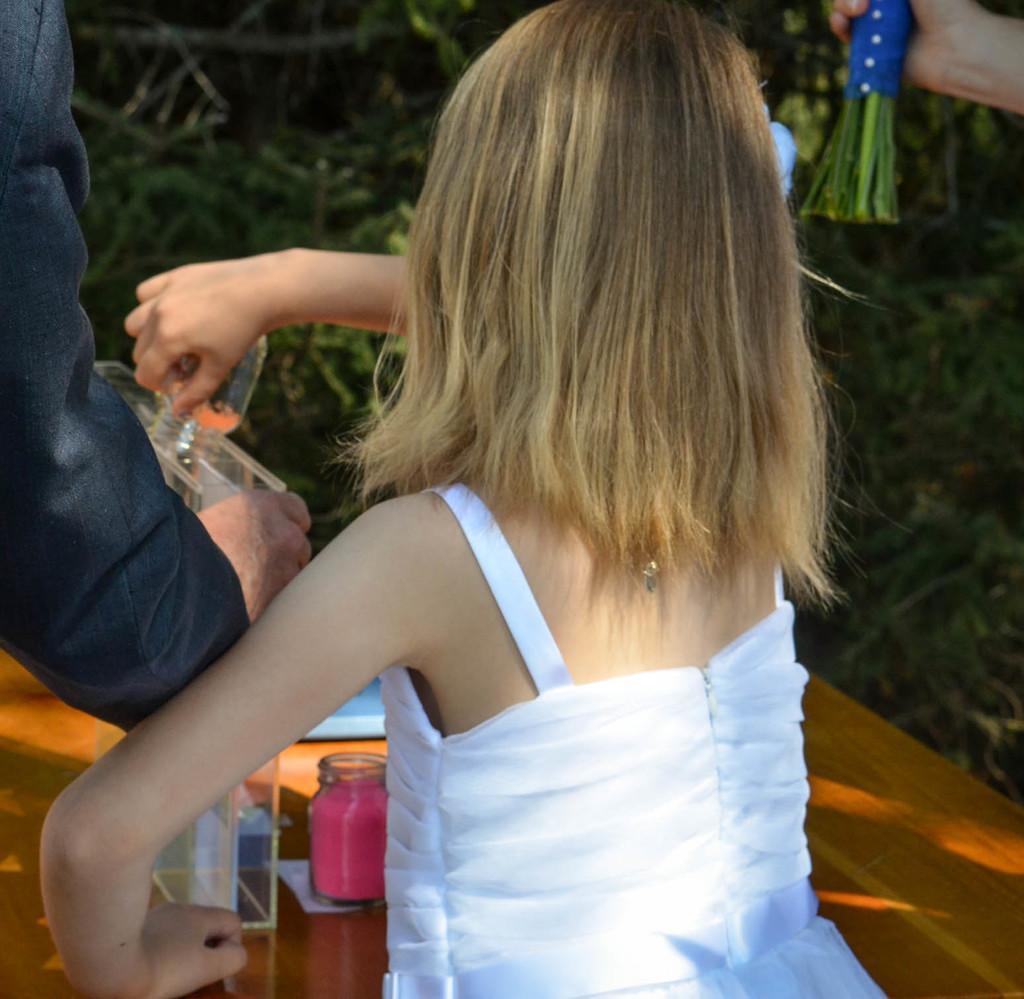In one or two sentences, can you explain what this image depicts? Here in the middle we can see a child in a white colored dress standing over there and in front of her we can see a table present, on which we can see some color bottles present over there and beside her on either side we can see some people standing over there and in front her we can see plants present over there. 